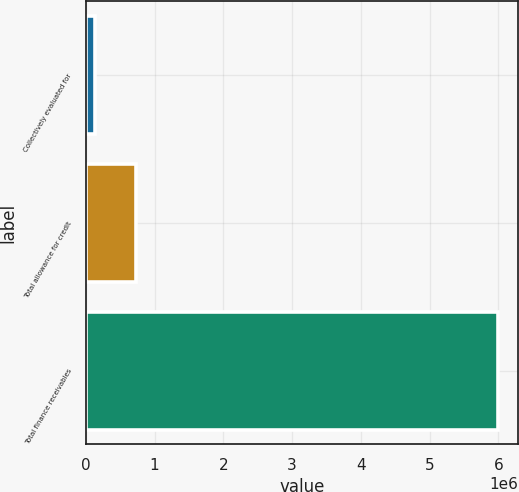Convert chart. <chart><loc_0><loc_0><loc_500><loc_500><bar_chart><fcel>Collectively evaluated for<fcel>Total allowance for credit<fcel>Total finance receivables<nl><fcel>139320<fcel>724535<fcel>5.99147e+06<nl></chart> 